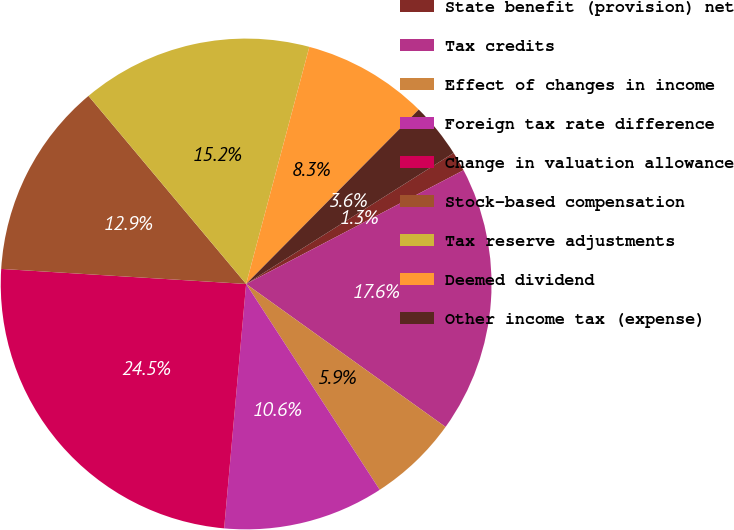Convert chart. <chart><loc_0><loc_0><loc_500><loc_500><pie_chart><fcel>State benefit (provision) net<fcel>Tax credits<fcel>Effect of changes in income<fcel>Foreign tax rate difference<fcel>Change in valuation allowance<fcel>Stock-based compensation<fcel>Tax reserve adjustments<fcel>Deemed dividend<fcel>Other income tax (expense)<nl><fcel>1.29%<fcel>17.57%<fcel>5.94%<fcel>10.59%<fcel>24.55%<fcel>12.92%<fcel>15.25%<fcel>8.27%<fcel>3.62%<nl></chart> 